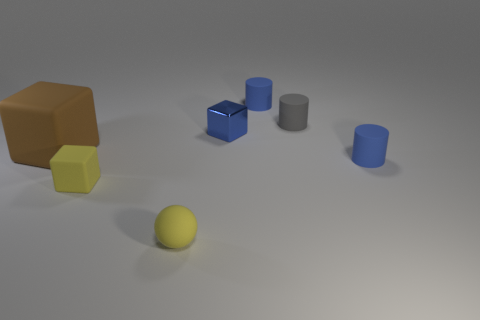Add 2 blue rubber cylinders. How many objects exist? 9 Subtract all balls. How many objects are left? 6 Subtract all gray rubber cylinders. Subtract all large matte objects. How many objects are left? 5 Add 5 tiny balls. How many tiny balls are left? 6 Add 2 tiny green matte things. How many tiny green matte things exist? 2 Subtract 0 green spheres. How many objects are left? 7 